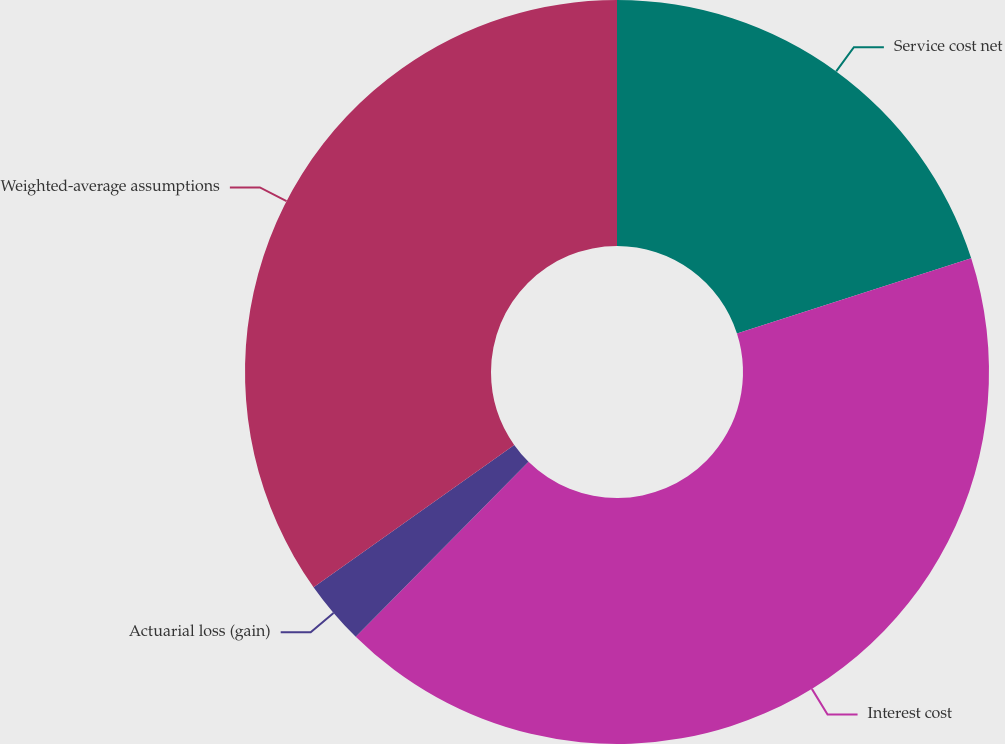Convert chart to OTSL. <chart><loc_0><loc_0><loc_500><loc_500><pie_chart><fcel>Service cost net<fcel>Interest cost<fcel>Actuarial loss (gain)<fcel>Weighted-average assumptions<nl><fcel>20.06%<fcel>42.34%<fcel>2.79%<fcel>34.82%<nl></chart> 